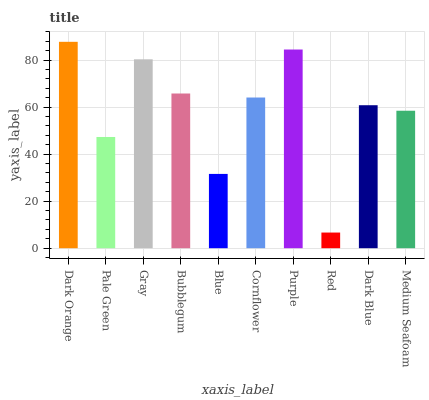Is Red the minimum?
Answer yes or no. Yes. Is Dark Orange the maximum?
Answer yes or no. Yes. Is Pale Green the minimum?
Answer yes or no. No. Is Pale Green the maximum?
Answer yes or no. No. Is Dark Orange greater than Pale Green?
Answer yes or no. Yes. Is Pale Green less than Dark Orange?
Answer yes or no. Yes. Is Pale Green greater than Dark Orange?
Answer yes or no. No. Is Dark Orange less than Pale Green?
Answer yes or no. No. Is Cornflower the high median?
Answer yes or no. Yes. Is Dark Blue the low median?
Answer yes or no. Yes. Is Pale Green the high median?
Answer yes or no. No. Is Medium Seafoam the low median?
Answer yes or no. No. 